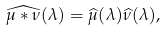Convert formula to latex. <formula><loc_0><loc_0><loc_500><loc_500>\widehat { \mu * \nu } ( \lambda ) = \widehat { \mu } ( \lambda ) \widehat { \nu } ( \lambda ) ,</formula> 